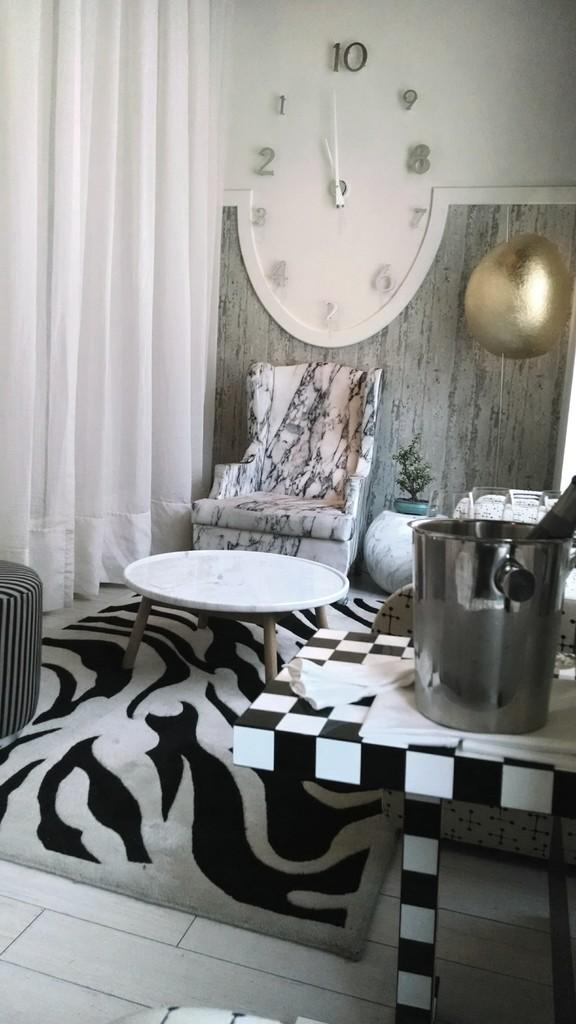<image>
Share a concise interpretation of the image provided. A huge oval clock points to the number 10. 